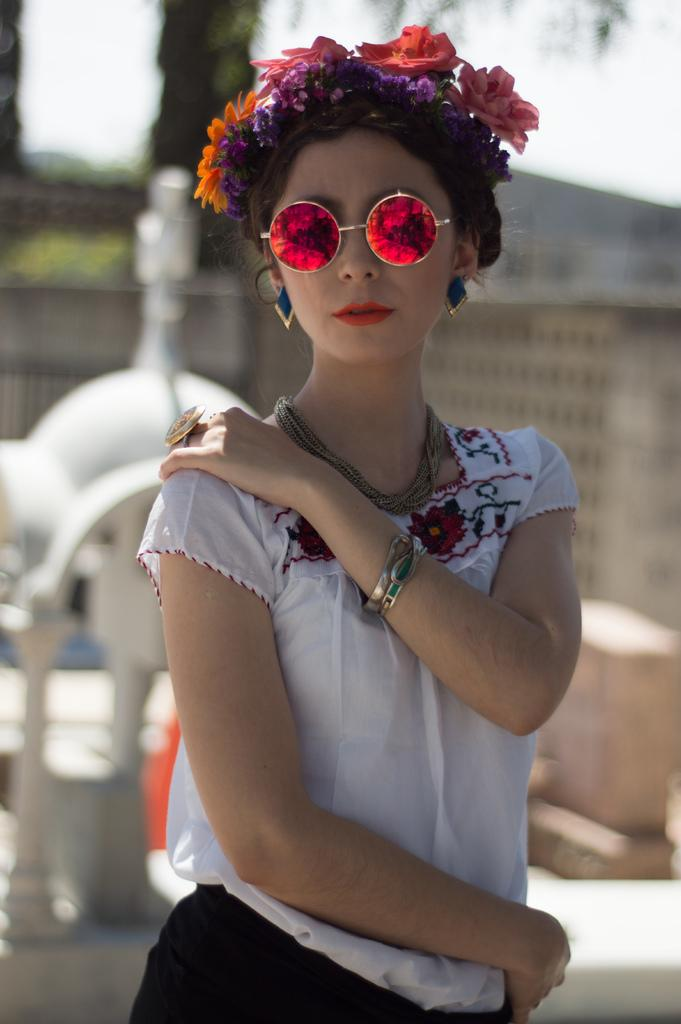What is the nationality of the girl in the picture? The girl in the picture is Chinese. What is the girl wearing on her upper body? The girl is wearing a white top. What accessory is the girl wearing on her head? The girl has a flower band on her head. What is the girl doing in the picture? The girl is standing and posing for the camera. How is the background of the image depicted? The background of the image is blurred. What type of blood is visible on the girl's face in the image? There is no blood visible on the girl's face in the image. What is the girl's afterthought about the picture? The image does not provide any information about the girl's thoughts or feelings after the picture was taken. 